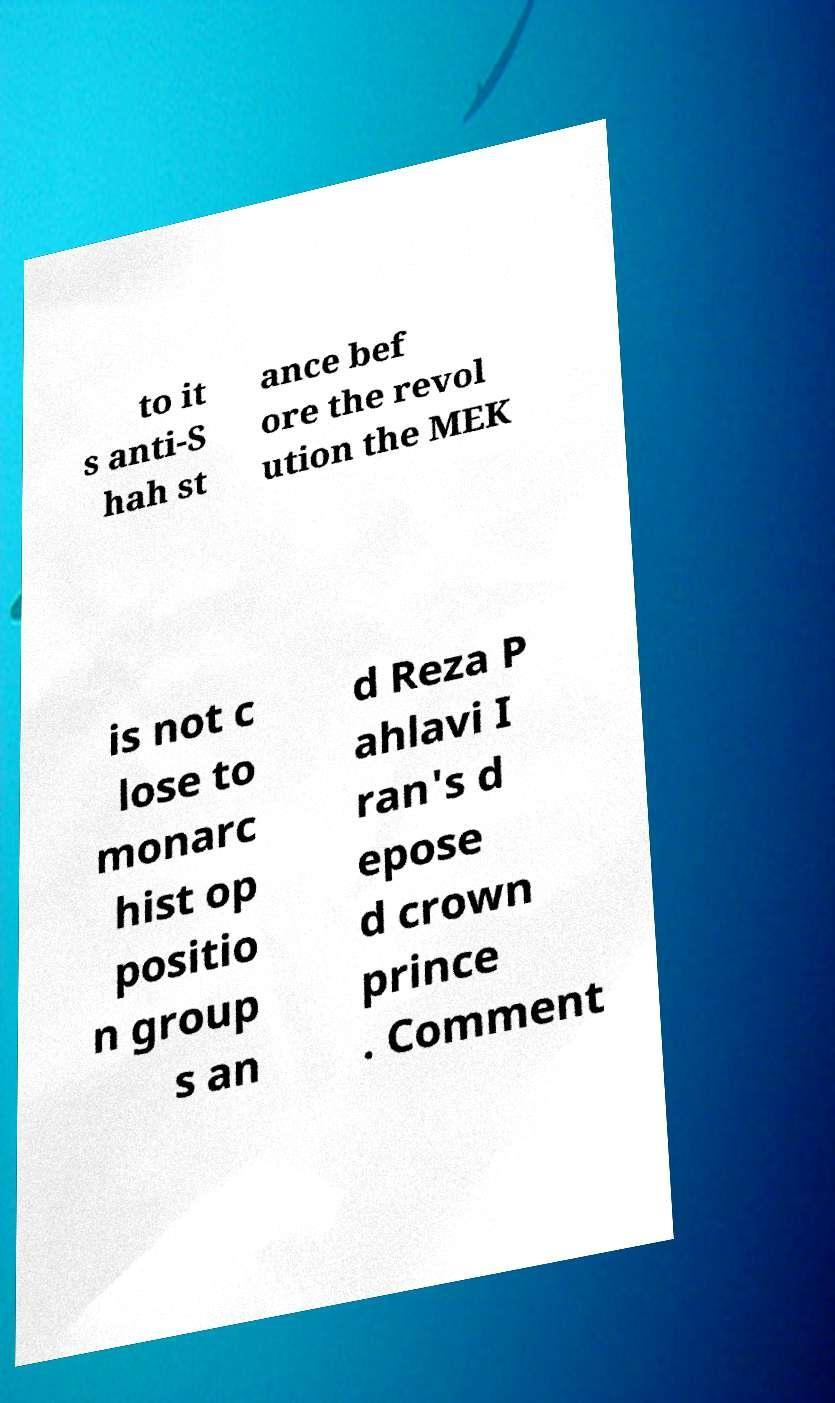For documentation purposes, I need the text within this image transcribed. Could you provide that? to it s anti-S hah st ance bef ore the revol ution the MEK is not c lose to monarc hist op positio n group s an d Reza P ahlavi I ran's d epose d crown prince . Comment 